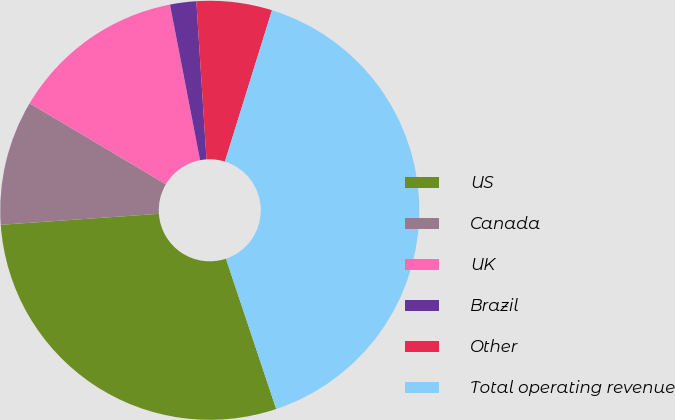<chart> <loc_0><loc_0><loc_500><loc_500><pie_chart><fcel>US<fcel>Canada<fcel>UK<fcel>Brazil<fcel>Other<fcel>Total operating revenue<nl><fcel>29.03%<fcel>9.63%<fcel>13.43%<fcel>2.02%<fcel>5.82%<fcel>40.06%<nl></chart> 